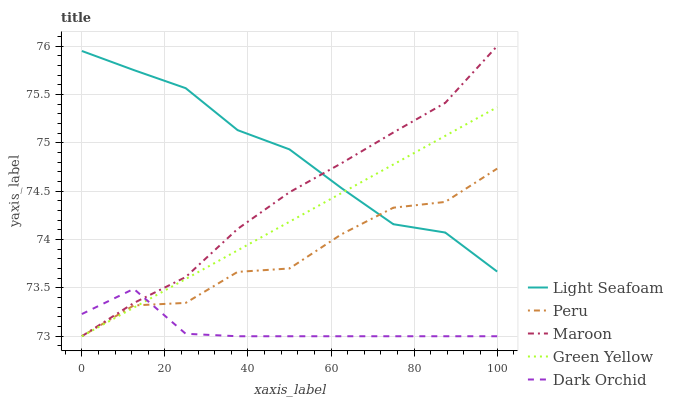Does Green Yellow have the minimum area under the curve?
Answer yes or no. No. Does Green Yellow have the maximum area under the curve?
Answer yes or no. No. Is Light Seafoam the smoothest?
Answer yes or no. No. Is Light Seafoam the roughest?
Answer yes or no. No. Does Light Seafoam have the lowest value?
Answer yes or no. No. Does Green Yellow have the highest value?
Answer yes or no. No. Is Dark Orchid less than Light Seafoam?
Answer yes or no. Yes. Is Light Seafoam greater than Dark Orchid?
Answer yes or no. Yes. Does Dark Orchid intersect Light Seafoam?
Answer yes or no. No. 